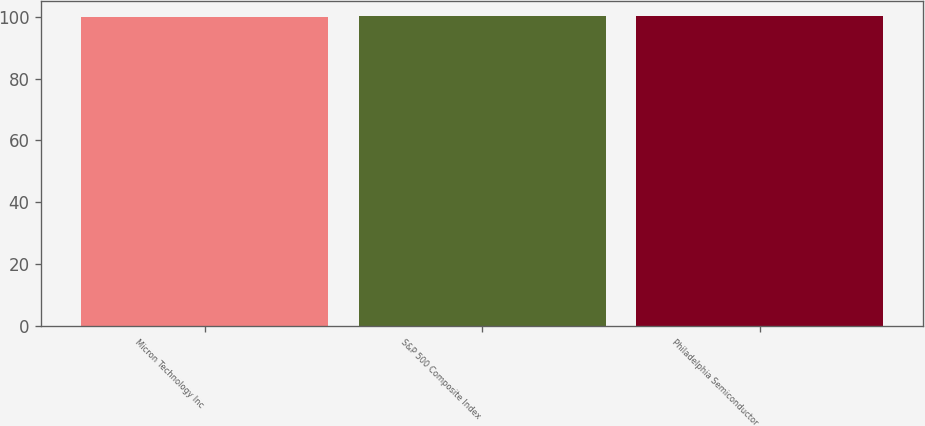<chart> <loc_0><loc_0><loc_500><loc_500><bar_chart><fcel>Micron Technology Inc<fcel>S&P 500 Composite Index<fcel>Philadelphia Semiconductor<nl><fcel>100<fcel>100.1<fcel>100.2<nl></chart> 